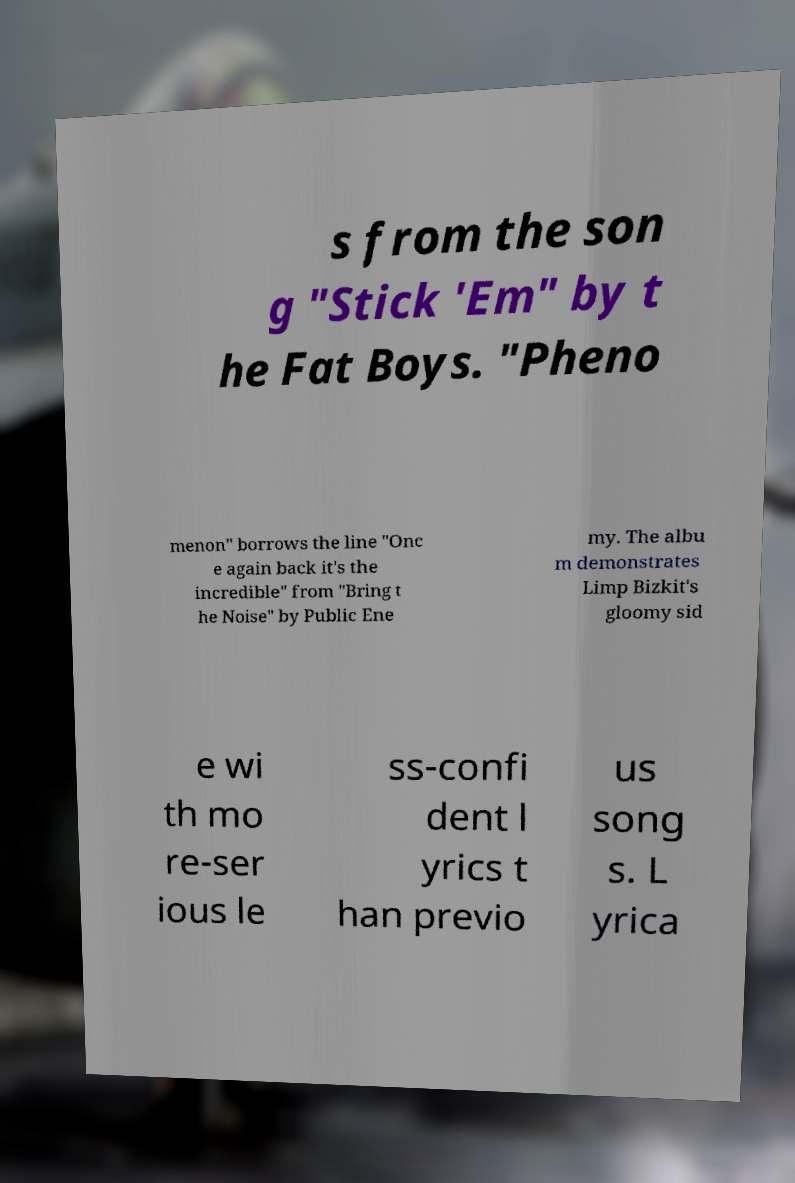Please read and relay the text visible in this image. What does it say? s from the son g "Stick 'Em" by t he Fat Boys. "Pheno menon" borrows the line "Onc e again back it's the incredible" from "Bring t he Noise" by Public Ene my. The albu m demonstrates Limp Bizkit's gloomy sid e wi th mo re-ser ious le ss-confi dent l yrics t han previo us song s. L yrica 